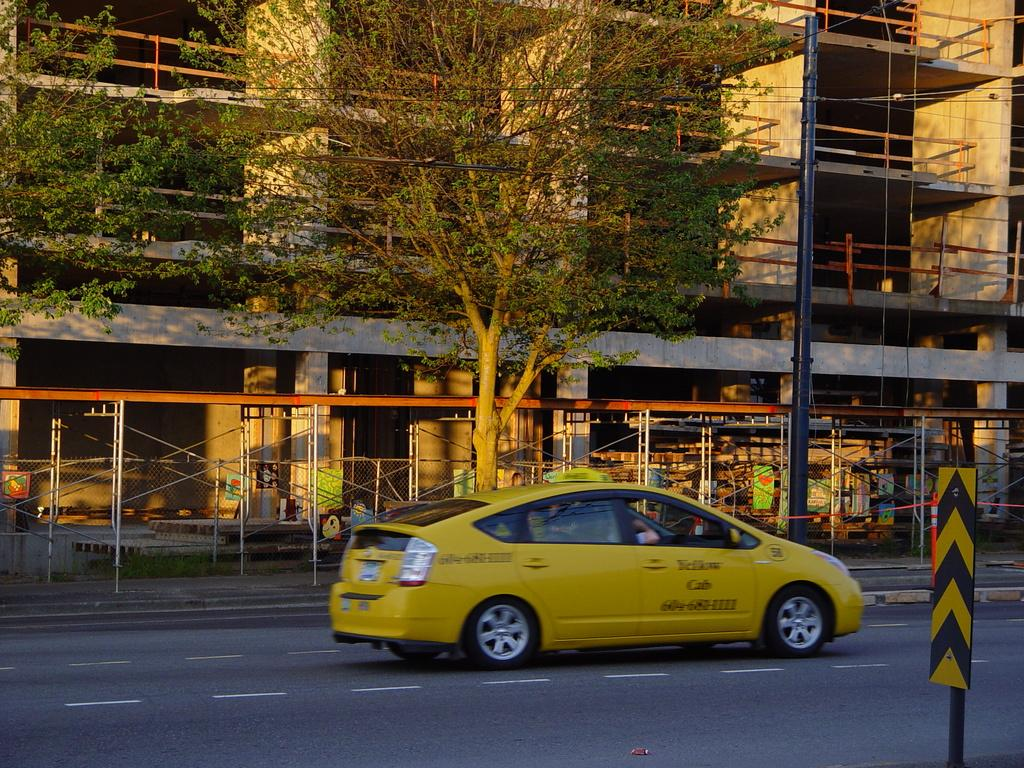<image>
Provide a brief description of the given image. A yellow Prius that says Yellow Cab is driving down a road by a construction site. 